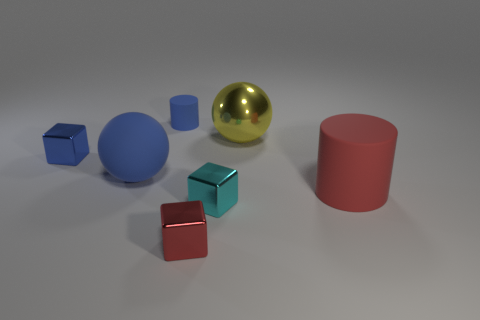Add 2 large blue things. How many objects exist? 9 Subtract all cylinders. How many objects are left? 5 Subtract 0 gray cubes. How many objects are left? 7 Subtract all blue rubber cylinders. Subtract all yellow metallic things. How many objects are left? 5 Add 5 big red rubber cylinders. How many big red rubber cylinders are left? 6 Add 7 big matte spheres. How many big matte spheres exist? 8 